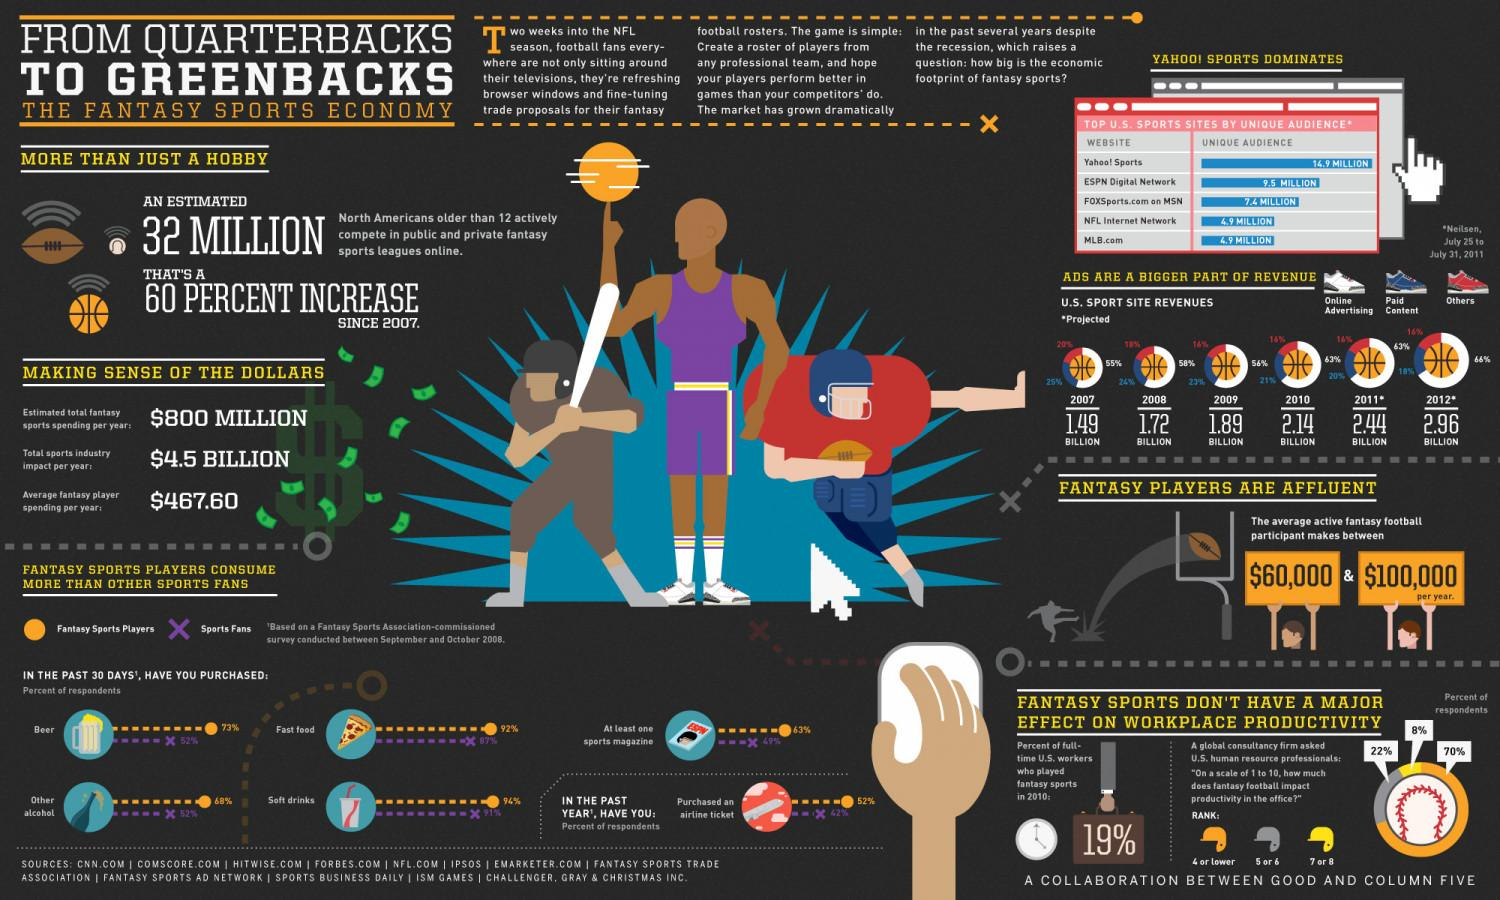Identify some key points in this picture. According to the respondents, 8% of them ranted about how much fantasy football impacts productivity in the office, with ratings of 7 or 8 on the question. The typical yearly earnings for an active and engaged fantasy football player range between sixty thousand and one hundred thousand dollars. In the last 30 days, 52% of people surveyed have not purchased beer or other types of alcohol. In 2009, the revenue of US sports sites from online advertising was 56%. According to projections for the US Sports site in 2011, revenues were expected to total 2.44 billion. 